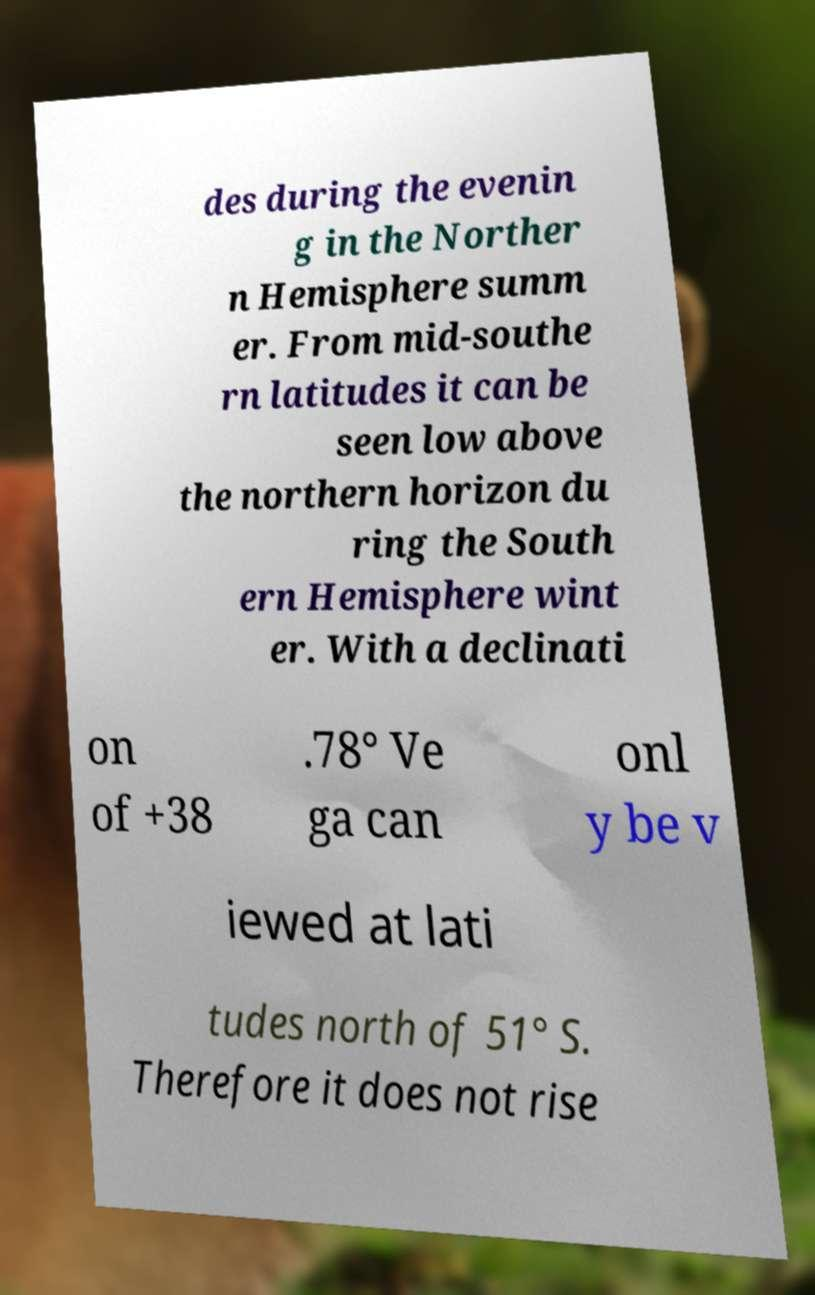Please identify and transcribe the text found in this image. des during the evenin g in the Norther n Hemisphere summ er. From mid-southe rn latitudes it can be seen low above the northern horizon du ring the South ern Hemisphere wint er. With a declinati on of +38 .78° Ve ga can onl y be v iewed at lati tudes north of 51° S. Therefore it does not rise 